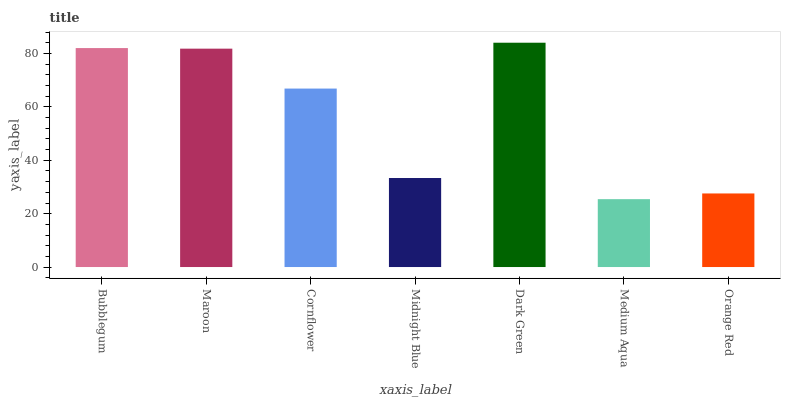Is Maroon the minimum?
Answer yes or no. No. Is Maroon the maximum?
Answer yes or no. No. Is Bubblegum greater than Maroon?
Answer yes or no. Yes. Is Maroon less than Bubblegum?
Answer yes or no. Yes. Is Maroon greater than Bubblegum?
Answer yes or no. No. Is Bubblegum less than Maroon?
Answer yes or no. No. Is Cornflower the high median?
Answer yes or no. Yes. Is Cornflower the low median?
Answer yes or no. Yes. Is Bubblegum the high median?
Answer yes or no. No. Is Medium Aqua the low median?
Answer yes or no. No. 